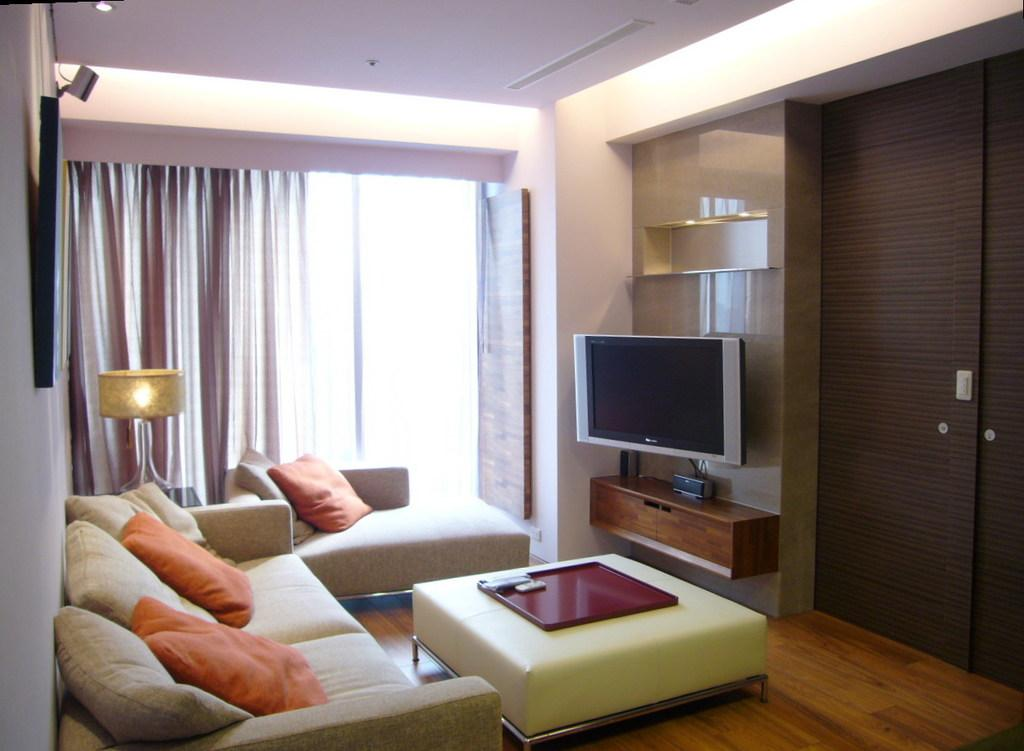What type of space is depicted in the image? There is a room in the image. What furniture is present in the room? There is a sofa with pillows and a table with a tray in the room. What can be seen in the background of the room? There is a window with curtains, a lamp, a television, racks, and a door in the background. What type of ornament is hanging from the ceiling in the image? There is no ornament hanging from the ceiling in the image. How does the society depicted in the image function? The image does not depict a society, so it is not possible to determine how it functions. 